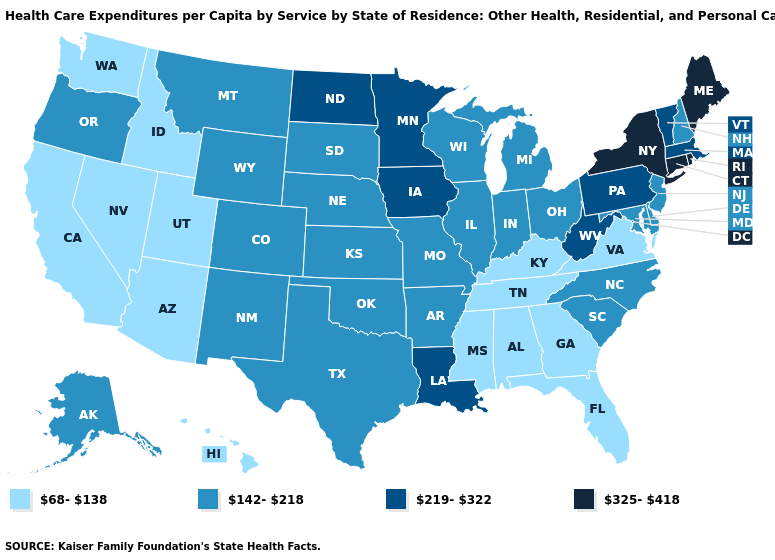Does Connecticut have a lower value than Kentucky?
Give a very brief answer. No. Name the states that have a value in the range 325-418?
Short answer required. Connecticut, Maine, New York, Rhode Island. Name the states that have a value in the range 142-218?
Answer briefly. Alaska, Arkansas, Colorado, Delaware, Illinois, Indiana, Kansas, Maryland, Michigan, Missouri, Montana, Nebraska, New Hampshire, New Jersey, New Mexico, North Carolina, Ohio, Oklahoma, Oregon, South Carolina, South Dakota, Texas, Wisconsin, Wyoming. What is the value of Alaska?
Give a very brief answer. 142-218. Name the states that have a value in the range 68-138?
Be succinct. Alabama, Arizona, California, Florida, Georgia, Hawaii, Idaho, Kentucky, Mississippi, Nevada, Tennessee, Utah, Virginia, Washington. Among the states that border Montana , which have the highest value?
Quick response, please. North Dakota. What is the lowest value in states that border Oklahoma?
Write a very short answer. 142-218. What is the value of Arizona?
Concise answer only. 68-138. Does New York have a higher value than Louisiana?
Answer briefly. Yes. Among the states that border North Dakota , does Montana have the highest value?
Write a very short answer. No. Does Connecticut have the highest value in the USA?
Write a very short answer. Yes. What is the value of Illinois?
Write a very short answer. 142-218. Which states have the lowest value in the South?
Be succinct. Alabama, Florida, Georgia, Kentucky, Mississippi, Tennessee, Virginia. Name the states that have a value in the range 142-218?
Give a very brief answer. Alaska, Arkansas, Colorado, Delaware, Illinois, Indiana, Kansas, Maryland, Michigan, Missouri, Montana, Nebraska, New Hampshire, New Jersey, New Mexico, North Carolina, Ohio, Oklahoma, Oregon, South Carolina, South Dakota, Texas, Wisconsin, Wyoming. 